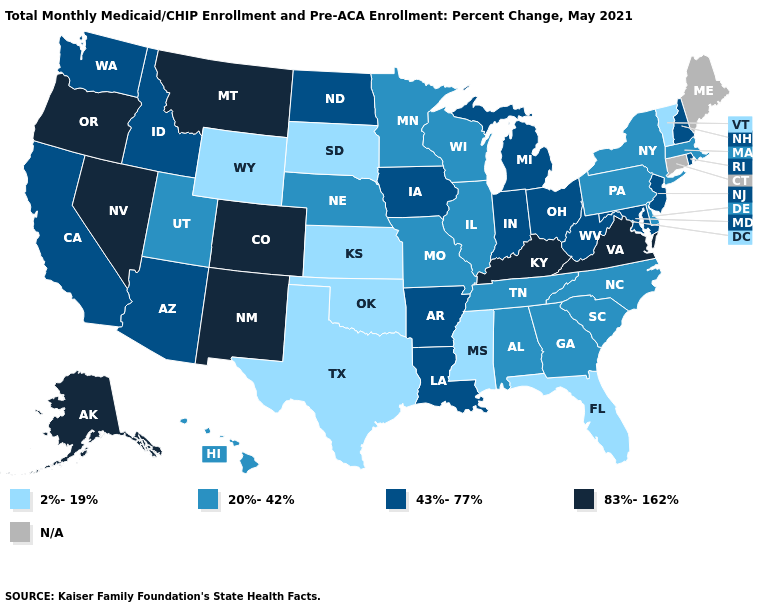Name the states that have a value in the range 83%-162%?
Keep it brief. Alaska, Colorado, Kentucky, Montana, Nevada, New Mexico, Oregon, Virginia. Name the states that have a value in the range 83%-162%?
Concise answer only. Alaska, Colorado, Kentucky, Montana, Nevada, New Mexico, Oregon, Virginia. Name the states that have a value in the range N/A?
Give a very brief answer. Connecticut, Maine. Name the states that have a value in the range 43%-77%?
Answer briefly. Arizona, Arkansas, California, Idaho, Indiana, Iowa, Louisiana, Maryland, Michigan, New Hampshire, New Jersey, North Dakota, Ohio, Rhode Island, Washington, West Virginia. What is the value of Utah?
Be succinct. 20%-42%. Name the states that have a value in the range 83%-162%?
Short answer required. Alaska, Colorado, Kentucky, Montana, Nevada, New Mexico, Oregon, Virginia. Among the states that border Massachusetts , does New York have the lowest value?
Keep it brief. No. What is the value of South Carolina?
Keep it brief. 20%-42%. What is the value of Nebraska?
Concise answer only. 20%-42%. Name the states that have a value in the range 83%-162%?
Give a very brief answer. Alaska, Colorado, Kentucky, Montana, Nevada, New Mexico, Oregon, Virginia. What is the value of North Carolina?
Be succinct. 20%-42%. Which states hav the highest value in the Northeast?
Be succinct. New Hampshire, New Jersey, Rhode Island. Does Kansas have the lowest value in the MidWest?
Give a very brief answer. Yes. Does the first symbol in the legend represent the smallest category?
Concise answer only. Yes. 